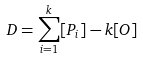<formula> <loc_0><loc_0><loc_500><loc_500>D = \sum _ { i = 1 } ^ { k } [ P _ { i } ] - k [ O ]</formula> 